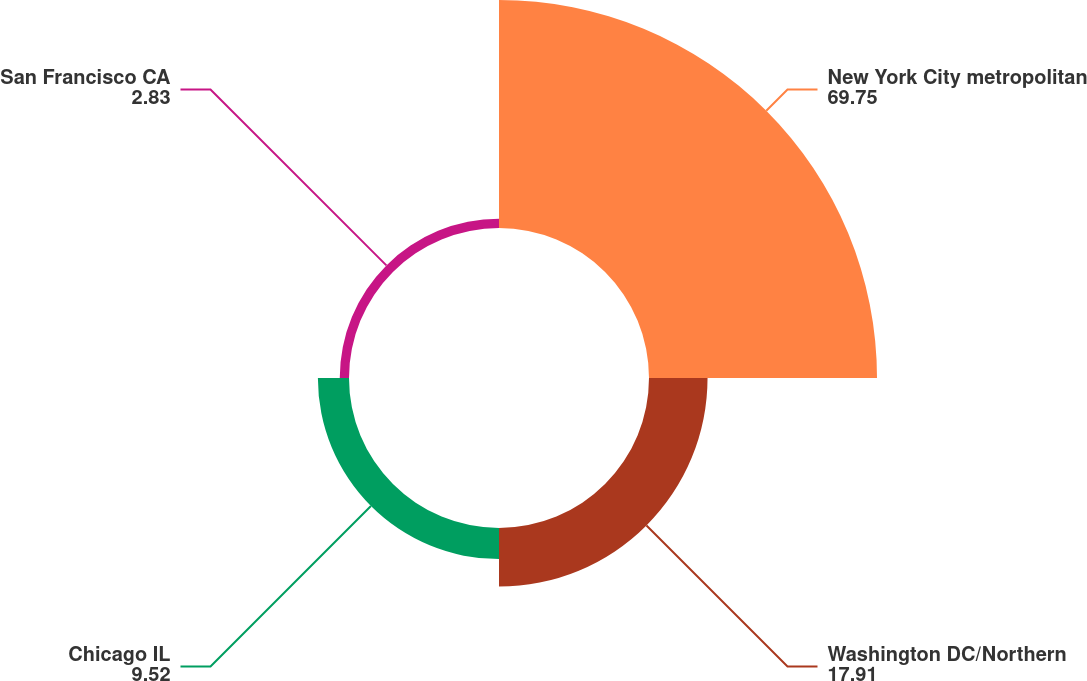Convert chart. <chart><loc_0><loc_0><loc_500><loc_500><pie_chart><fcel>New York City metropolitan<fcel>Washington DC/Northern<fcel>Chicago IL<fcel>San Francisco CA<nl><fcel>69.75%<fcel>17.91%<fcel>9.52%<fcel>2.83%<nl></chart> 